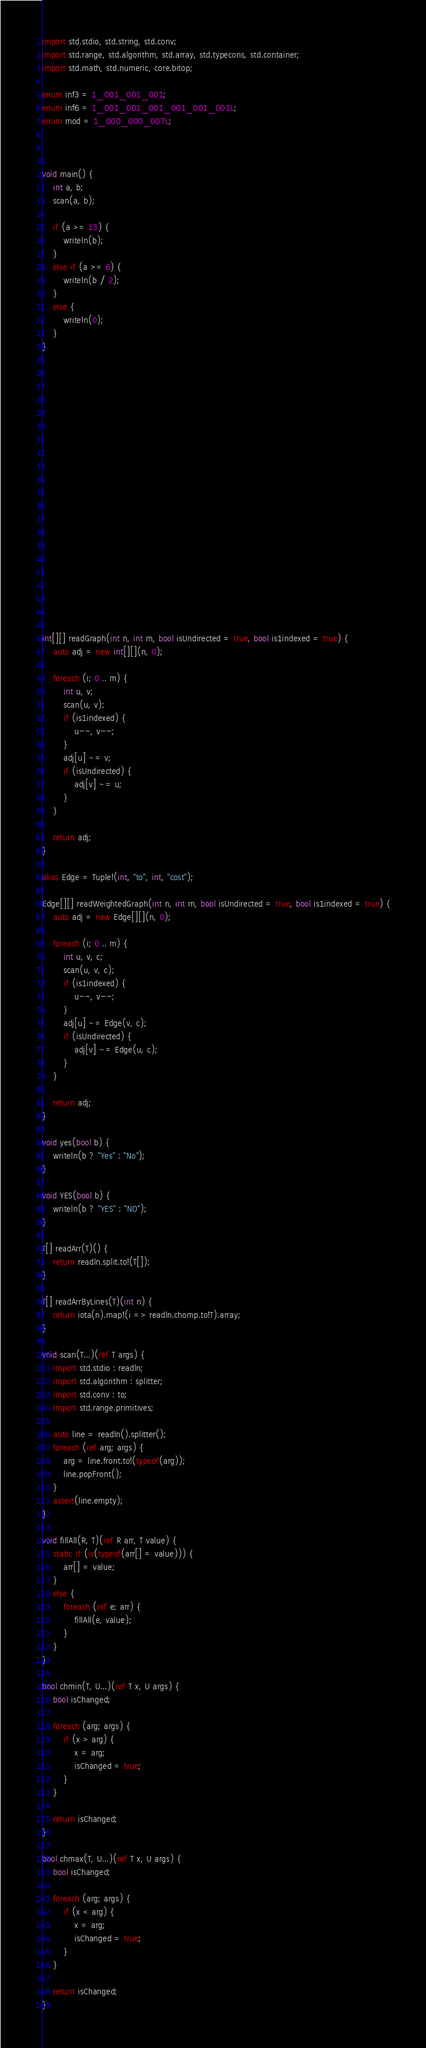Convert code to text. <code><loc_0><loc_0><loc_500><loc_500><_D_>import std.stdio, std.string, std.conv;
import std.range, std.algorithm, std.array, std.typecons, std.container;
import std.math, std.numeric, core.bitop;

enum inf3 = 1_001_001_001;
enum inf6 = 1_001_001_001_001_001_001L;
enum mod = 1_000_000_007L;



void main() {
    int a, b;
    scan(a, b);

    if (a >= 13) {
        writeln(b);
    }
    else if (a >= 6) {
        writeln(b / 2);
    }
    else {
        writeln(0);
    }
}





















int[][] readGraph(int n, int m, bool isUndirected = true, bool is1indexed = true) {
    auto adj = new int[][](n, 0);

    foreach (i; 0 .. m) {
        int u, v;
        scan(u, v);
        if (is1indexed) {
            u--, v--;
        }
        adj[u] ~= v;
        if (isUndirected) {
            adj[v] ~= u;
        }
    }

    return adj;
}

alias Edge = Tuple!(int, "to", int, "cost");

Edge[][] readWeightedGraph(int n, int m, bool isUndirected = true, bool is1indexed = true) {
    auto adj = new Edge[][](n, 0);

    foreach (i; 0 .. m) {
        int u, v, c;
        scan(u, v, c);
        if (is1indexed) {
            u--, v--;
        }
        adj[u] ~= Edge(v, c);
        if (isUndirected) {
            adj[v] ~= Edge(u, c);
        }
    }

    return adj;
}

void yes(bool b) {
    writeln(b ? "Yes" : "No");
}

void YES(bool b) {
    writeln(b ? "YES" : "NO");
}

T[] readArr(T)() {
    return readln.split.to!(T[]);
}

T[] readArrByLines(T)(int n) {
    return iota(n).map!(i => readln.chomp.to!T).array;
}

void scan(T...)(ref T args) {
    import std.stdio : readln;
    import std.algorithm : splitter;
    import std.conv : to;
    import std.range.primitives;

    auto line = readln().splitter();
    foreach (ref arg; args) {
        arg = line.front.to!(typeof(arg));
        line.popFront();
    }
    assert(line.empty);
}

void fillAll(R, T)(ref R arr, T value) {
    static if (is(typeof(arr[] = value))) {
        arr[] = value;
    }
    else {
        foreach (ref e; arr) {
            fillAll(e, value);
        }
    }
}

bool chmin(T, U...)(ref T x, U args) {
    bool isChanged;

    foreach (arg; args) {
        if (x > arg) {
            x = arg;
            isChanged = true;
        }
    }

    return isChanged;
}

bool chmax(T, U...)(ref T x, U args) {
    bool isChanged;

    foreach (arg; args) {
        if (x < arg) {
            x = arg;
            isChanged = true;
        }
    }

    return isChanged;
}
</code> 